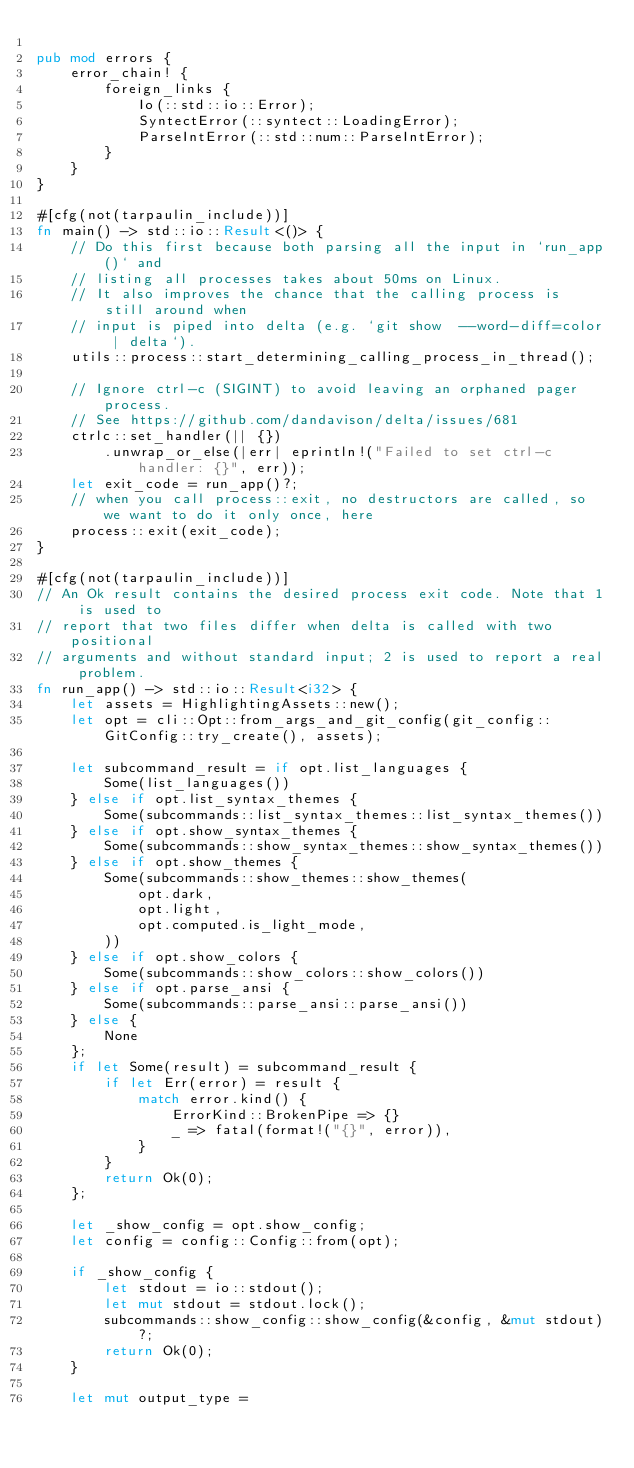<code> <loc_0><loc_0><loc_500><loc_500><_Rust_>
pub mod errors {
    error_chain! {
        foreign_links {
            Io(::std::io::Error);
            SyntectError(::syntect::LoadingError);
            ParseIntError(::std::num::ParseIntError);
        }
    }
}

#[cfg(not(tarpaulin_include))]
fn main() -> std::io::Result<()> {
    // Do this first because both parsing all the input in `run_app()` and
    // listing all processes takes about 50ms on Linux.
    // It also improves the chance that the calling process is still around when
    // input is piped into delta (e.g. `git show  --word-diff=color | delta`).
    utils::process::start_determining_calling_process_in_thread();

    // Ignore ctrl-c (SIGINT) to avoid leaving an orphaned pager process.
    // See https://github.com/dandavison/delta/issues/681
    ctrlc::set_handler(|| {})
        .unwrap_or_else(|err| eprintln!("Failed to set ctrl-c handler: {}", err));
    let exit_code = run_app()?;
    // when you call process::exit, no destructors are called, so we want to do it only once, here
    process::exit(exit_code);
}

#[cfg(not(tarpaulin_include))]
// An Ok result contains the desired process exit code. Note that 1 is used to
// report that two files differ when delta is called with two positional
// arguments and without standard input; 2 is used to report a real problem.
fn run_app() -> std::io::Result<i32> {
    let assets = HighlightingAssets::new();
    let opt = cli::Opt::from_args_and_git_config(git_config::GitConfig::try_create(), assets);

    let subcommand_result = if opt.list_languages {
        Some(list_languages())
    } else if opt.list_syntax_themes {
        Some(subcommands::list_syntax_themes::list_syntax_themes())
    } else if opt.show_syntax_themes {
        Some(subcommands::show_syntax_themes::show_syntax_themes())
    } else if opt.show_themes {
        Some(subcommands::show_themes::show_themes(
            opt.dark,
            opt.light,
            opt.computed.is_light_mode,
        ))
    } else if opt.show_colors {
        Some(subcommands::show_colors::show_colors())
    } else if opt.parse_ansi {
        Some(subcommands::parse_ansi::parse_ansi())
    } else {
        None
    };
    if let Some(result) = subcommand_result {
        if let Err(error) = result {
            match error.kind() {
                ErrorKind::BrokenPipe => {}
                _ => fatal(format!("{}", error)),
            }
        }
        return Ok(0);
    };

    let _show_config = opt.show_config;
    let config = config::Config::from(opt);

    if _show_config {
        let stdout = io::stdout();
        let mut stdout = stdout.lock();
        subcommands::show_config::show_config(&config, &mut stdout)?;
        return Ok(0);
    }

    let mut output_type =</code> 